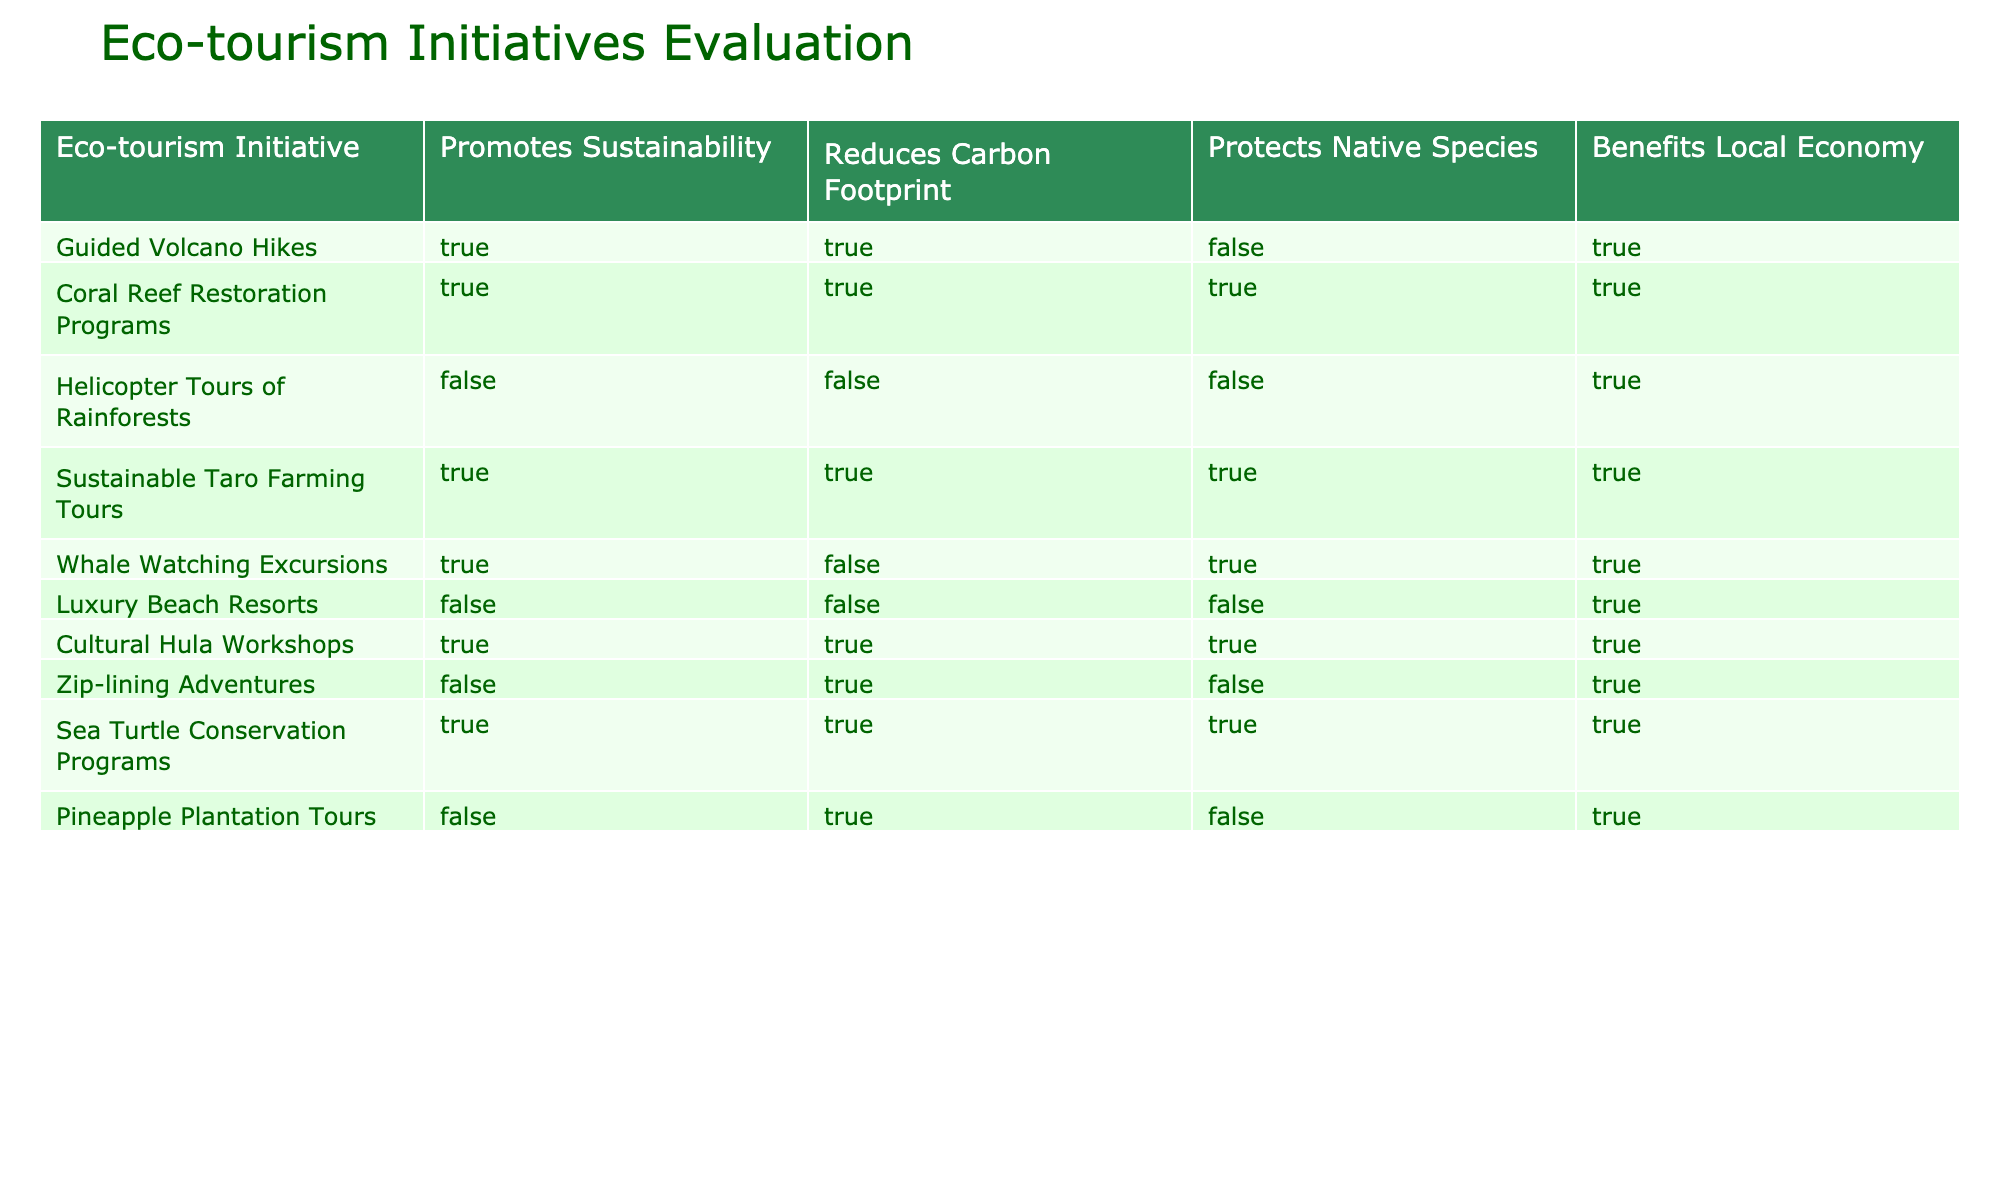What eco-tourism initiative protects native species? The table lists several eco-tourism initiatives and indicates which ones protect native species with a TRUE or FALSE value. By scanning through the "Protects Native Species" column, I can see that the initiatives marked as TRUE are Coral Reef Restoration Programs, Sustainable Taro Farming Tours, Whale Watching Excursions, Cultural Hula Workshops, and Sea Turtle Conservation Programs.
Answer: Coral Reef Restoration Programs, Sustainable Taro Farming Tours, Whale Watching Excursions, Cultural Hula Workshops, Sea Turtle Conservation Programs How many initiatives promote sustainability but do not reduce the carbon footprint? I first look at the "Promotes Sustainability" column and identify the initiatives with a TRUE value. Then, from this list, I check the "Reduces Carbon Footprint" column to see which of these has a FALSE value. The initiatives that meet these criteria are Whale Watching Excursions and Cultural Hula Workshops. Therefore, there are 2 initiatives.
Answer: 2 Do any eco-tourism initiatives both reduce carbon footprint and benefit the local economy? I check the "Reduces Carbon Footprint" column for TRUE values and then look for the initiatives that also have a TRUE value in the "Benefits Local Economy" column. The initiatives that satisfy both conditions are Guided Volcano Hikes, Coral Reef Restoration Programs, Sustainable Taro Farming Tours, Whale Watching Excursions, Zip-lining Adventures, and Cultural Hula Workshops.
Answer: Yes What is the total number of initiatives listed in the table? I count all the rows in the table to determine the total number of eco-tourism initiatives listed. There are 10 initiatives in total as indicated by the rows provided.
Answer: 10 Which eco-tourism initiatives benefit the local economy but do not promote sustainability? I need to find initiatives that have TRUE in the "Benefits Local Economy" column and FALSE in the "Promotes Sustainability" column. Scanning the table, I find that the initiatives that fit this criterion are Helicopter Tours of Rainforests, Luxury Beach Resorts, and Pineapple Plantation Tours. They benefit the local economy but do not promote sustainability.
Answer: Helicopter Tours of Rainforests, Luxury Beach Resorts, Pineapple Plantation Tours 